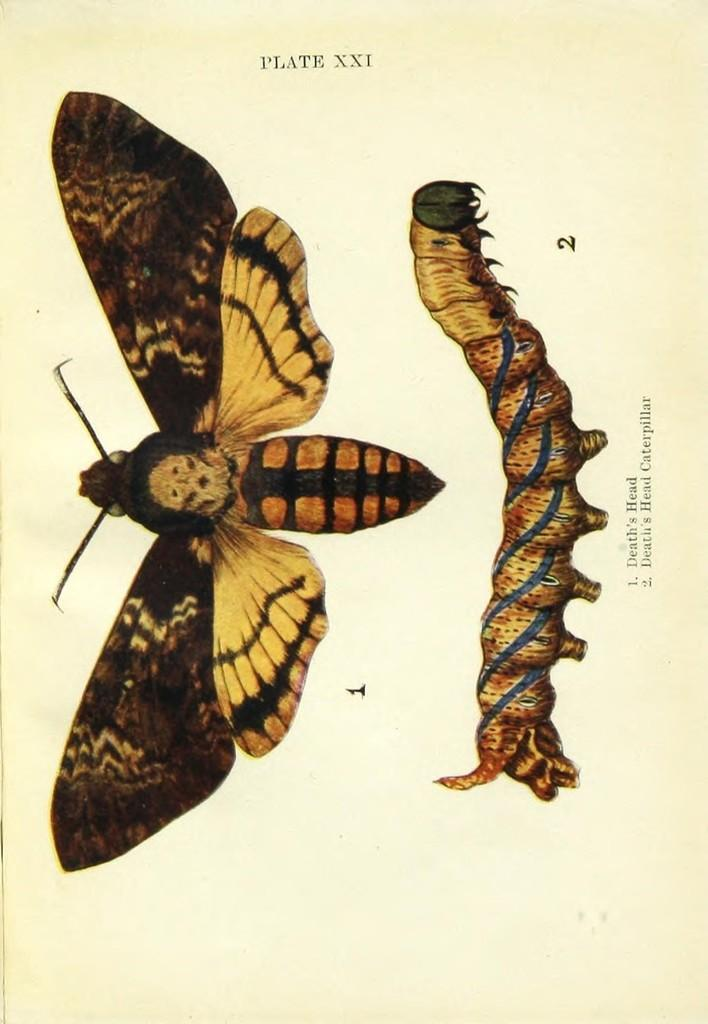What type of insects are depicted in the image? There is a picture of a butterfly and a caterpillar in the image. What else can be seen in the image besides the insects? There is text present in the image. What type of drug is being used to help the caterpillar learn in the image? There is no drug or learning depicted in the image; it only features a butterfly and a caterpillar with accompanying text. 